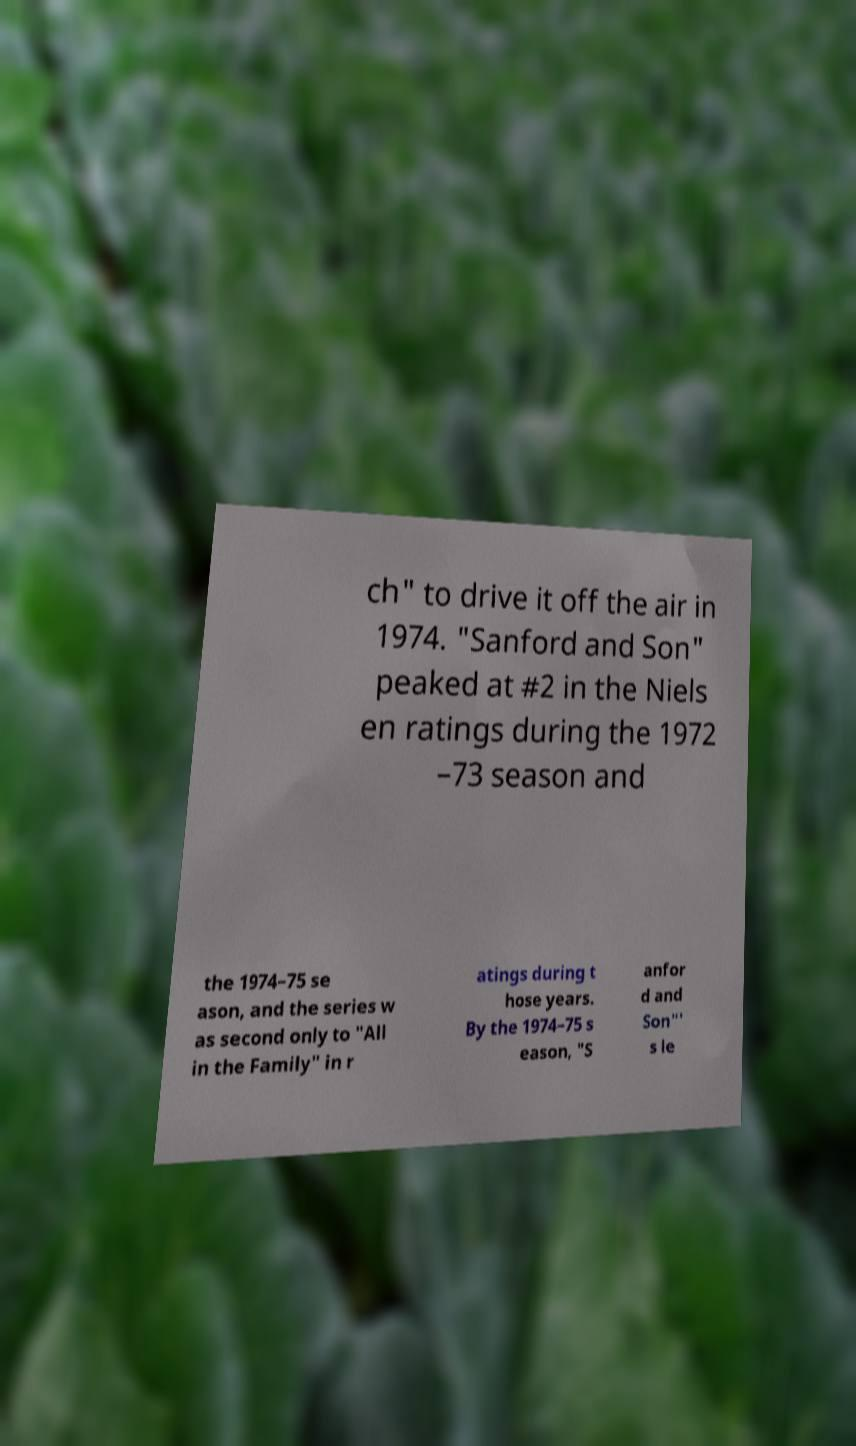Please read and relay the text visible in this image. What does it say? ch" to drive it off the air in 1974. "Sanford and Son" peaked at #2 in the Niels en ratings during the 1972 –73 season and the 1974–75 se ason, and the series w as second only to "All in the Family" in r atings during t hose years. By the 1974–75 s eason, "S anfor d and Son"' s le 